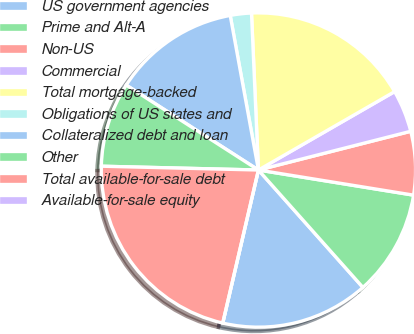<chart> <loc_0><loc_0><loc_500><loc_500><pie_chart><fcel>US government agencies<fcel>Prime and Alt-A<fcel>Non-US<fcel>Commercial<fcel>Total mortgage-backed<fcel>Obligations of US states and<fcel>Collateralized debt and loan<fcel>Other<fcel>Total available-for-sale debt<fcel>Available-for-sale equity<nl><fcel>15.22%<fcel>10.87%<fcel>6.52%<fcel>4.35%<fcel>17.39%<fcel>2.17%<fcel>13.04%<fcel>8.7%<fcel>21.74%<fcel>0.0%<nl></chart> 